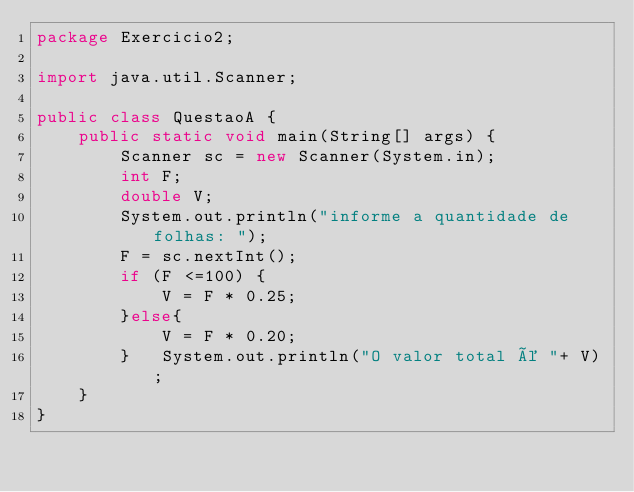Convert code to text. <code><loc_0><loc_0><loc_500><loc_500><_Java_>package Exercicio2;

import java.util.Scanner;

public class QuestaoA {
    public static void main(String[] args) {
        Scanner sc = new Scanner(System.in);
        int F;
        double V;
        System.out.println("informe a quantidade de folhas: ");
        F = sc.nextInt();
        if (F <=100) {
            V = F * 0.25;
        }else{
            V = F * 0.20;
        }   System.out.println("O valor total é "+ V);
    }
}</code> 